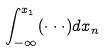<formula> <loc_0><loc_0><loc_500><loc_500>\int _ { - \infty } ^ { x _ { 1 } } ( \cdot \cdot \cdot ) d x _ { n }</formula> 